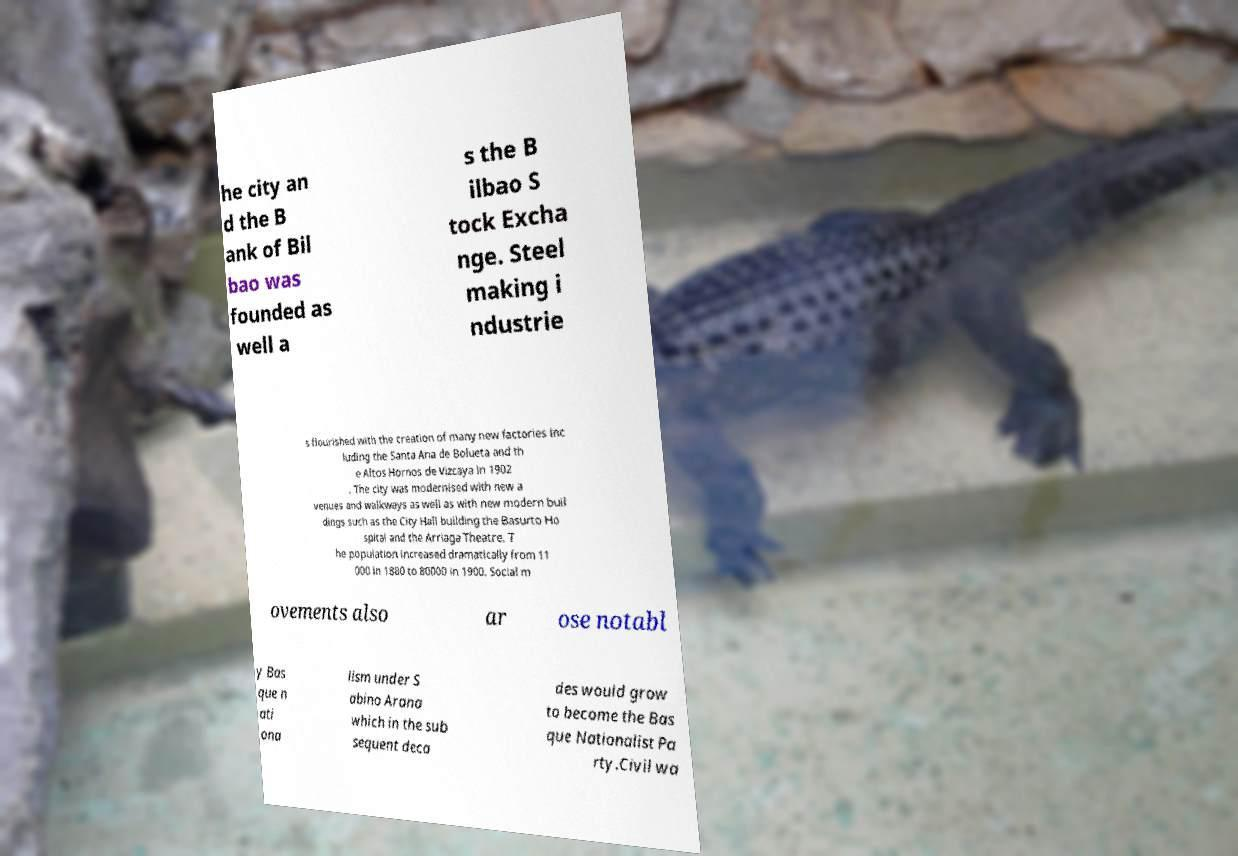Could you assist in decoding the text presented in this image and type it out clearly? he city an d the B ank of Bil bao was founded as well a s the B ilbao S tock Excha nge. Steel making i ndustrie s flourished with the creation of many new factories inc luding the Santa Ana de Bolueta and th e Altos Hornos de Vizcaya in 1902 . The city was modernised with new a venues and walkways as well as with new modern buil dings such as the City Hall building the Basurto Ho spital and the Arriaga Theatre. T he population increased dramatically from 11 000 in 1880 to 80000 in 1900. Social m ovements also ar ose notabl y Bas que n ati ona lism under S abino Arana which in the sub sequent deca des would grow to become the Bas que Nationalist Pa rty.Civil wa 